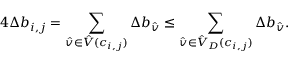<formula> <loc_0><loc_0><loc_500><loc_500>4 \Delta b _ { i , j } = \sum _ { \hat { v } \in \hat { V } ( c _ { i , j } ) } \Delta b _ { \hat { v } } \leq \sum _ { \hat { v } \in \hat { V } _ { D } ( c _ { i , j } ) } \Delta b _ { \hat { v } } .</formula> 